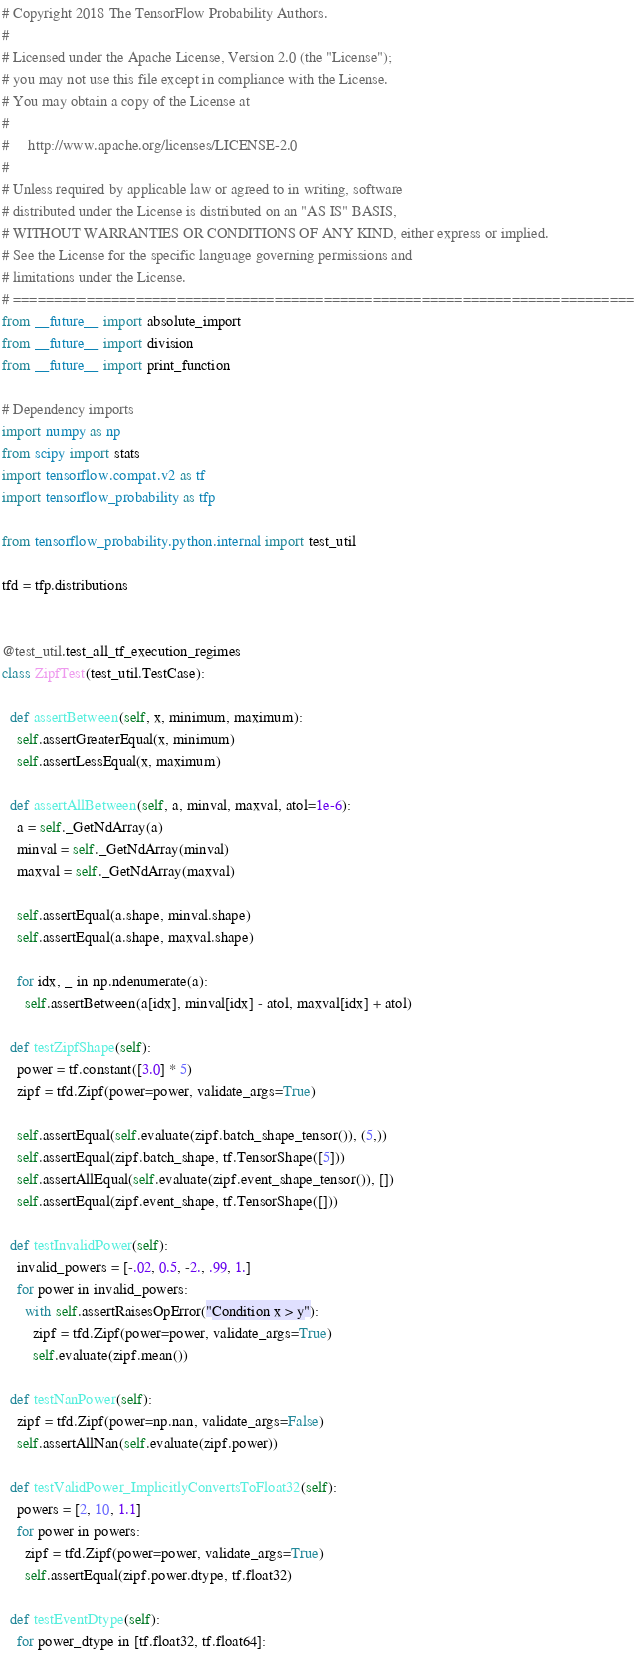Convert code to text. <code><loc_0><loc_0><loc_500><loc_500><_Python_># Copyright 2018 The TensorFlow Probability Authors.
#
# Licensed under the Apache License, Version 2.0 (the "License");
# you may not use this file except in compliance with the License.
# You may obtain a copy of the License at
#
#     http://www.apache.org/licenses/LICENSE-2.0
#
# Unless required by applicable law or agreed to in writing, software
# distributed under the License is distributed on an "AS IS" BASIS,
# WITHOUT WARRANTIES OR CONDITIONS OF ANY KIND, either express or implied.
# See the License for the specific language governing permissions and
# limitations under the License.
# ============================================================================
from __future__ import absolute_import
from __future__ import division
from __future__ import print_function

# Dependency imports
import numpy as np
from scipy import stats
import tensorflow.compat.v2 as tf
import tensorflow_probability as tfp

from tensorflow_probability.python.internal import test_util

tfd = tfp.distributions


@test_util.test_all_tf_execution_regimes
class ZipfTest(test_util.TestCase):

  def assertBetween(self, x, minimum, maximum):
    self.assertGreaterEqual(x, minimum)
    self.assertLessEqual(x, maximum)

  def assertAllBetween(self, a, minval, maxval, atol=1e-6):
    a = self._GetNdArray(a)
    minval = self._GetNdArray(minval)
    maxval = self._GetNdArray(maxval)

    self.assertEqual(a.shape, minval.shape)
    self.assertEqual(a.shape, maxval.shape)

    for idx, _ in np.ndenumerate(a):
      self.assertBetween(a[idx], minval[idx] - atol, maxval[idx] + atol)

  def testZipfShape(self):
    power = tf.constant([3.0] * 5)
    zipf = tfd.Zipf(power=power, validate_args=True)

    self.assertEqual(self.evaluate(zipf.batch_shape_tensor()), (5,))
    self.assertEqual(zipf.batch_shape, tf.TensorShape([5]))
    self.assertAllEqual(self.evaluate(zipf.event_shape_tensor()), [])
    self.assertEqual(zipf.event_shape, tf.TensorShape([]))

  def testInvalidPower(self):
    invalid_powers = [-.02, 0.5, -2., .99, 1.]
    for power in invalid_powers:
      with self.assertRaisesOpError("Condition x > y"):
        zipf = tfd.Zipf(power=power, validate_args=True)
        self.evaluate(zipf.mean())

  def testNanPower(self):
    zipf = tfd.Zipf(power=np.nan, validate_args=False)
    self.assertAllNan(self.evaluate(zipf.power))

  def testValidPower_ImplicitlyConvertsToFloat32(self):
    powers = [2, 10, 1.1]
    for power in powers:
      zipf = tfd.Zipf(power=power, validate_args=True)
      self.assertEqual(zipf.power.dtype, tf.float32)

  def testEventDtype(self):
    for power_dtype in [tf.float32, tf.float64]:</code> 